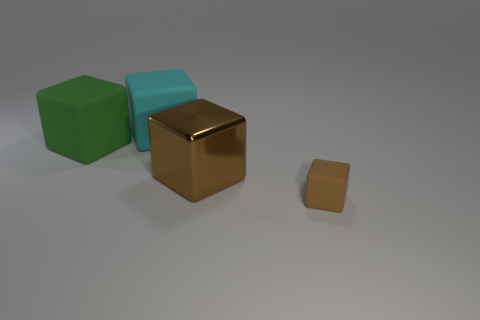There is a big cyan object that is made of the same material as the large green block; what is its shape?
Provide a short and direct response. Cube. How many green matte cubes are the same size as the cyan rubber cube?
Keep it short and to the point. 1. What number of matte objects are green things or big blocks?
Your response must be concise. 2. What is the cyan object made of?
Provide a succinct answer. Rubber. There is a big green rubber object; how many blocks are behind it?
Your response must be concise. 1. Is the object that is in front of the large brown block made of the same material as the cyan cube?
Make the answer very short. Yes. How many small objects have the same shape as the big brown object?
Your answer should be very brief. 1. What number of large objects are shiny cylinders or blocks?
Provide a succinct answer. 3. Is the color of the big object that is in front of the green cube the same as the tiny rubber thing?
Ensure brevity in your answer.  Yes. There is a block in front of the metal cube; is it the same color as the large matte thing on the left side of the cyan object?
Offer a very short reply. No. 